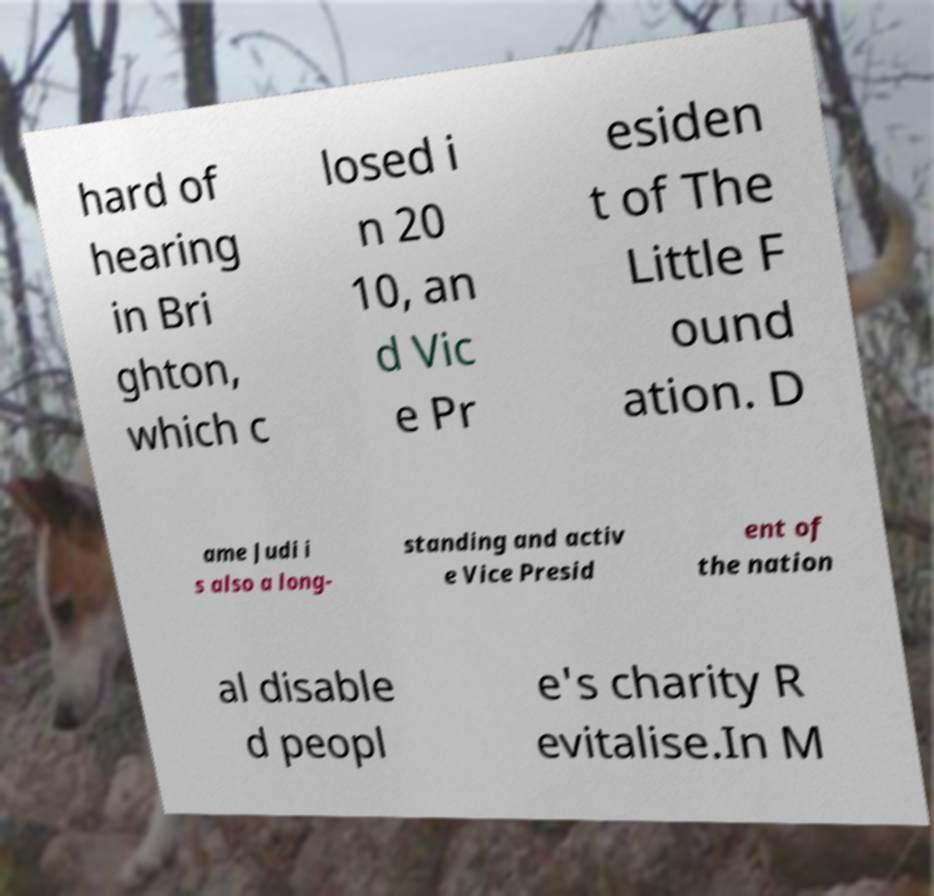Can you accurately transcribe the text from the provided image for me? hard of hearing in Bri ghton, which c losed i n 20 10, an d Vic e Pr esiden t of The Little F ound ation. D ame Judi i s also a long- standing and activ e Vice Presid ent of the nation al disable d peopl e's charity R evitalise.In M 